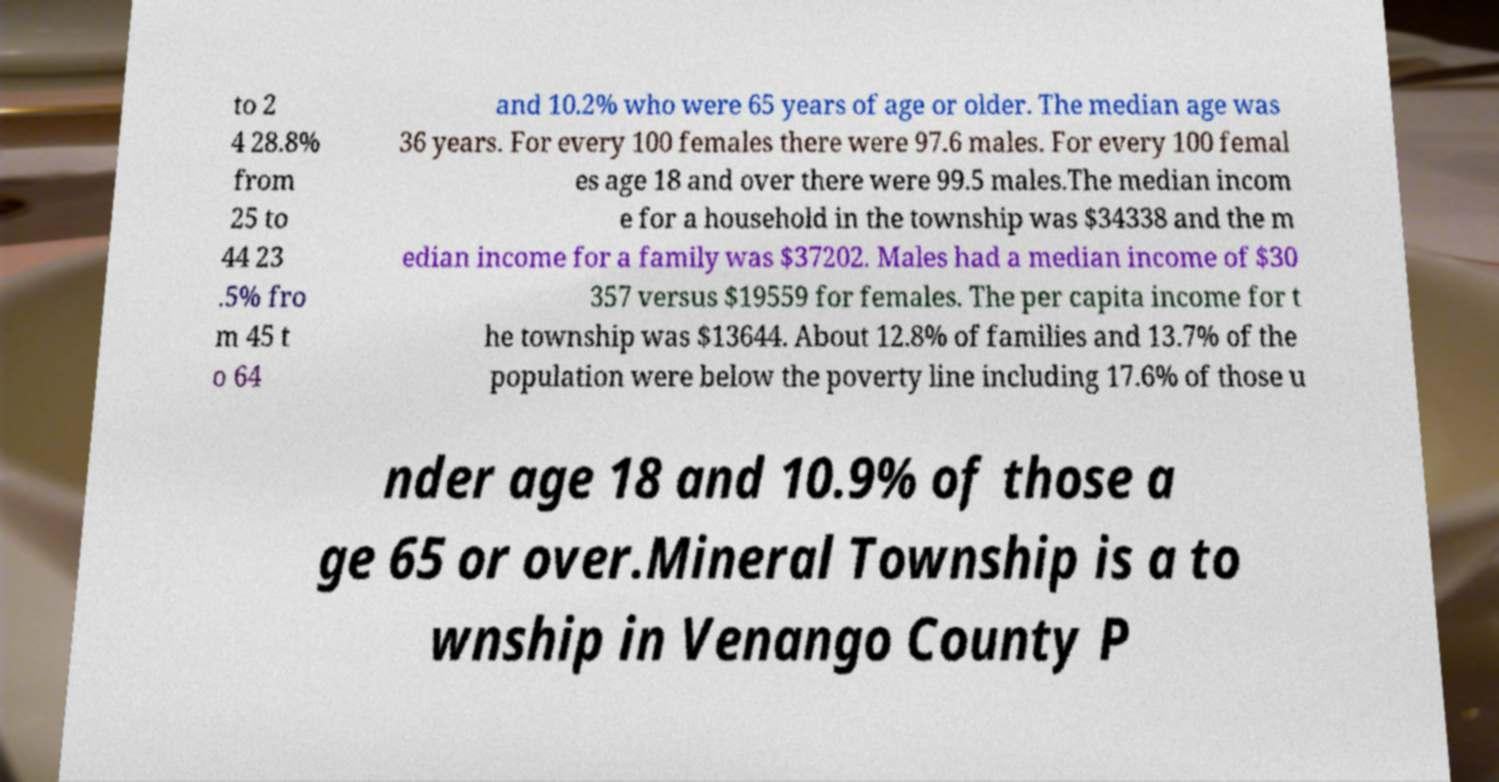There's text embedded in this image that I need extracted. Can you transcribe it verbatim? to 2 4 28.8% from 25 to 44 23 .5% fro m 45 t o 64 and 10.2% who were 65 years of age or older. The median age was 36 years. For every 100 females there were 97.6 males. For every 100 femal es age 18 and over there were 99.5 males.The median incom e for a household in the township was $34338 and the m edian income for a family was $37202. Males had a median income of $30 357 versus $19559 for females. The per capita income for t he township was $13644. About 12.8% of families and 13.7% of the population were below the poverty line including 17.6% of those u nder age 18 and 10.9% of those a ge 65 or over.Mineral Township is a to wnship in Venango County P 